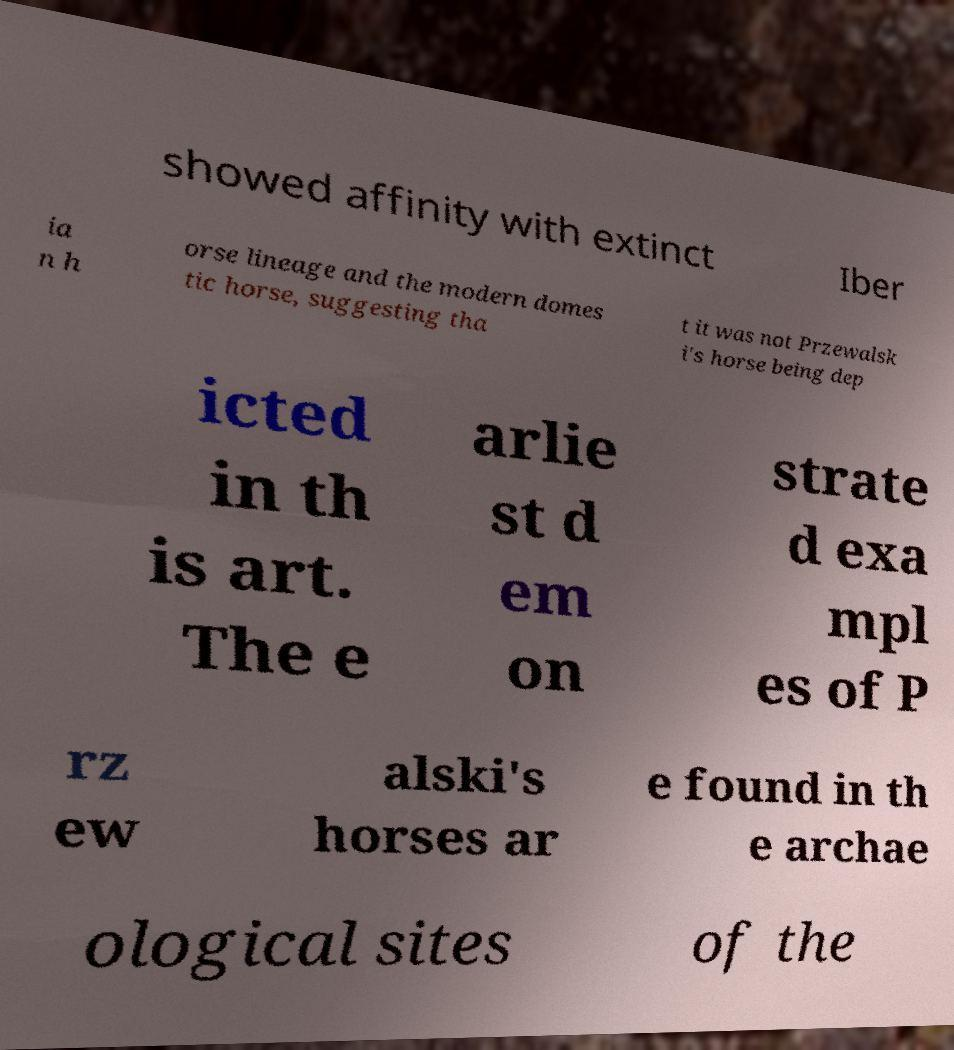Please read and relay the text visible in this image. What does it say? showed affinity with extinct Iber ia n h orse lineage and the modern domes tic horse, suggesting tha t it was not Przewalsk i's horse being dep icted in th is art. The e arlie st d em on strate d exa mpl es of P rz ew alski's horses ar e found in th e archae ological sites of the 